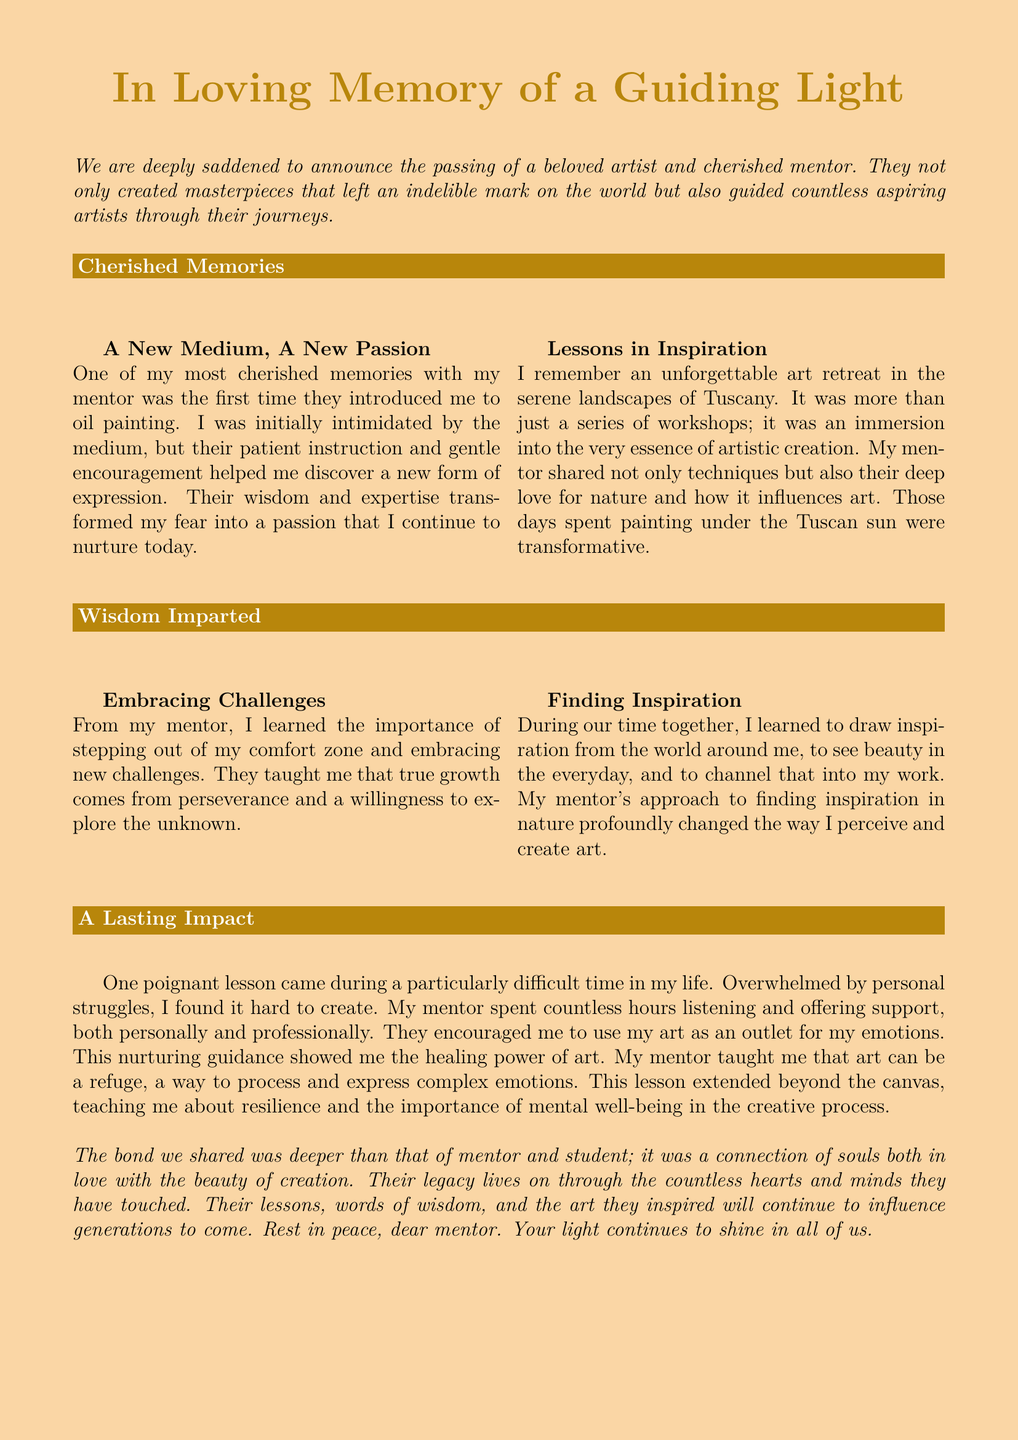What was a new medium that Latasha learned about? The document mentions that Latasha was introduced to oil painting by her mentor, which was a new medium for her.
Answer: oil painting Where did Latasha and her mentor attend an art retreat? The document states that Latasha and her mentor attended an art retreat in the serene landscapes of Tuscany.
Answer: Tuscany What important lesson did Latasha learn from her mentor about challenges? Latasha learned the importance of stepping out of her comfort zone and embracing new challenges.
Answer: embracing new challenges How did Latasha's mentor influence her perception of nature? Latasha learned to draw inspiration from the world around her, particularly from nature, through her mentor's teachings.
Answer: draw inspiration from nature What healing power did Latasha discover through her mentor's guidance? Latasha discovered that art can be a refuge and a way to process and express complex emotions.
Answer: healing power of art 